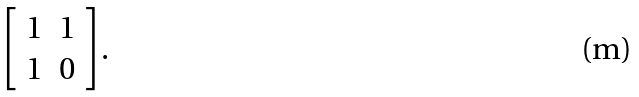<formula> <loc_0><loc_0><loc_500><loc_500>\left [ \begin{array} { c c } 1 & 1 \\ 1 & 0 \end{array} \right ] .</formula> 